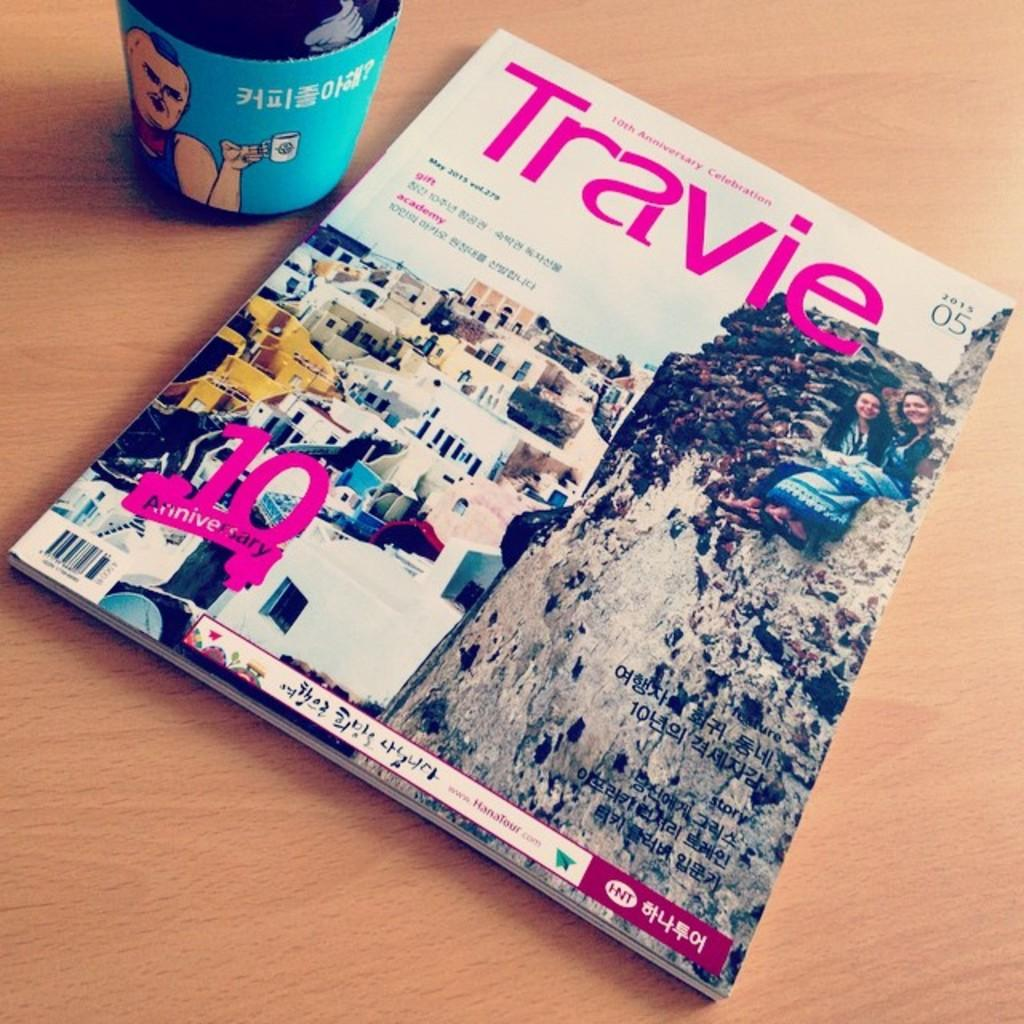<image>
Present a compact description of the photo's key features. A magazine, entitled Travie, is on top of a wood surface. 